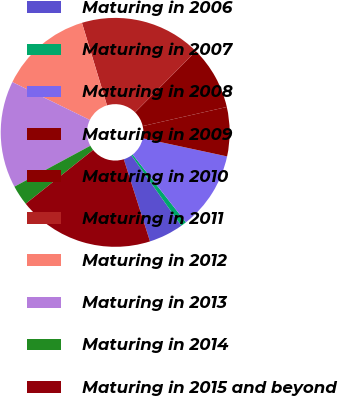<chart> <loc_0><loc_0><loc_500><loc_500><pie_chart><fcel>Maturing in 2006<fcel>Maturing in 2007<fcel>Maturing in 2008<fcel>Maturing in 2009<fcel>Maturing in 2010<fcel>Maturing in 2011<fcel>Maturing in 2012<fcel>Maturing in 2013<fcel>Maturing in 2014<fcel>Maturing in 2015 and beyond<nl><fcel>4.89%<fcel>0.8%<fcel>11.02%<fcel>6.93%<fcel>8.98%<fcel>17.15%<fcel>13.07%<fcel>15.11%<fcel>2.85%<fcel>19.2%<nl></chart> 